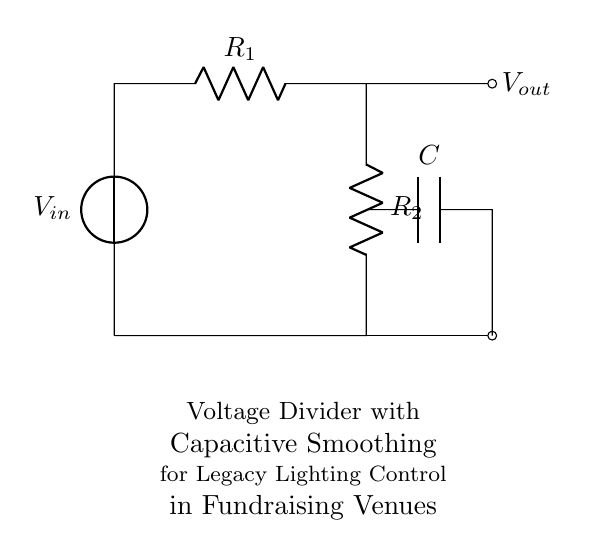What is the input voltage in this circuit? The input voltage is indicated as V_in, which represents the voltage provided to the circuit.
Answer: V_in How many resistors are in the circuit? There are two resistors labeled R_1 and R_2 in the circuit diagram.
Answer: 2 What is the role of the capacitor in this circuit? The capacitor, denoted as C, serves to smooth the output voltage by filtering any fluctuations or ripples, particularly useful in legacy lighting control applications.
Answer: Smoothing What are the output connections from the circuit? There are two output connections: one is labeled V_out (the output voltage from the voltage divider), and the other is a direct connection to the lower part of the circuit (ground).
Answer: V_out and ground If R1 is twice the value of R2, how will this affect the output voltage? If R1 is twice the value of R2, the output voltage (V_out) will be lower than half of V_in due to the voltage divider rule, specifically it becomes one-third of V_in (as governed by the formula V_out = V_in * (R2/(R1+R2))).
Answer: V_out = V_in / 3 What would happen to the output voltage if the capacitor were removed? Removing the capacitor would mean that the output voltage would experience more ripple, as the smoothing effect provided by the capacitor would be lost, leading to less stable lighting control in fundraising venues.
Answer: Increased ripple 